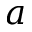<formula> <loc_0><loc_0><loc_500><loc_500>a</formula> 